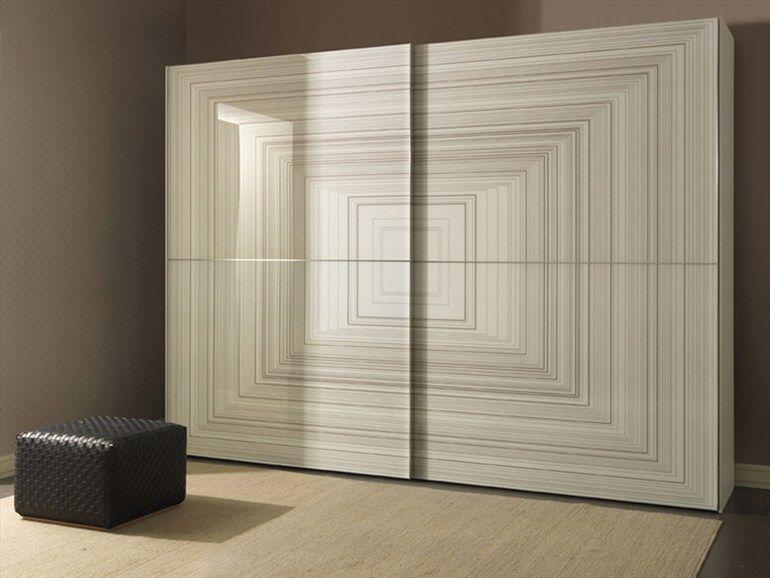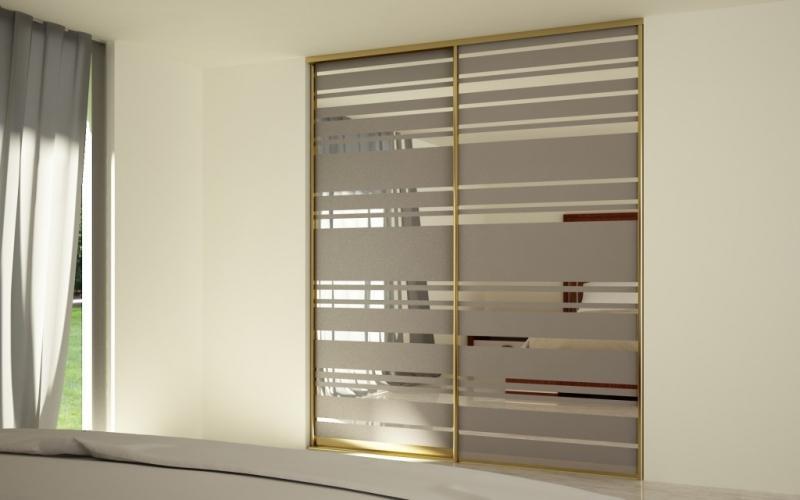The first image is the image on the left, the second image is the image on the right. Considering the images on both sides, is "The right image shows at least three earth-tone sliding doors with no embellishments." valid? Answer yes or no. No. 